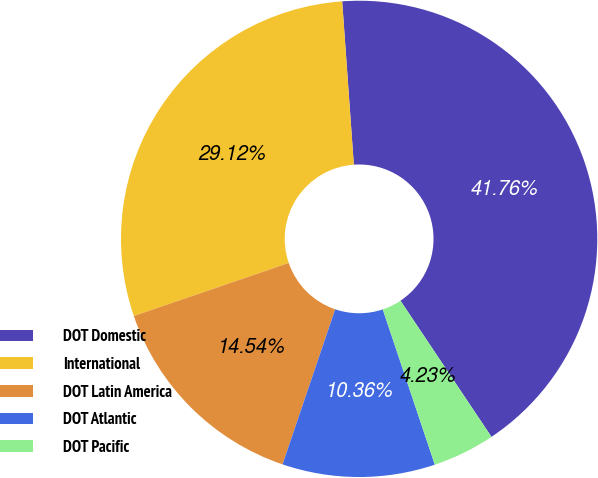<chart> <loc_0><loc_0><loc_500><loc_500><pie_chart><fcel>DOT Domestic<fcel>International<fcel>DOT Latin America<fcel>DOT Atlantic<fcel>DOT Pacific<nl><fcel>41.76%<fcel>29.12%<fcel>14.54%<fcel>10.36%<fcel>4.23%<nl></chart> 